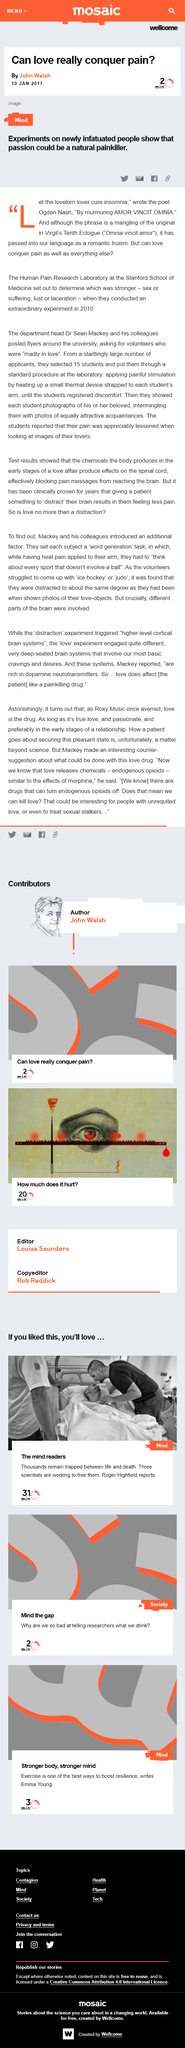Specify some key components in this picture. Mackey asserts that love has the power to alleviate physical pain, as it is a painkilling drug. The article was written by John Walsh on 10 January 2017, and it was published. Mackey and his colleague conducted an additional factor analysis, focusing on a word generation task. Dopamine neurotransmitters are rich in the following systems. This article is expected to take approximately 2 minutes to read. 